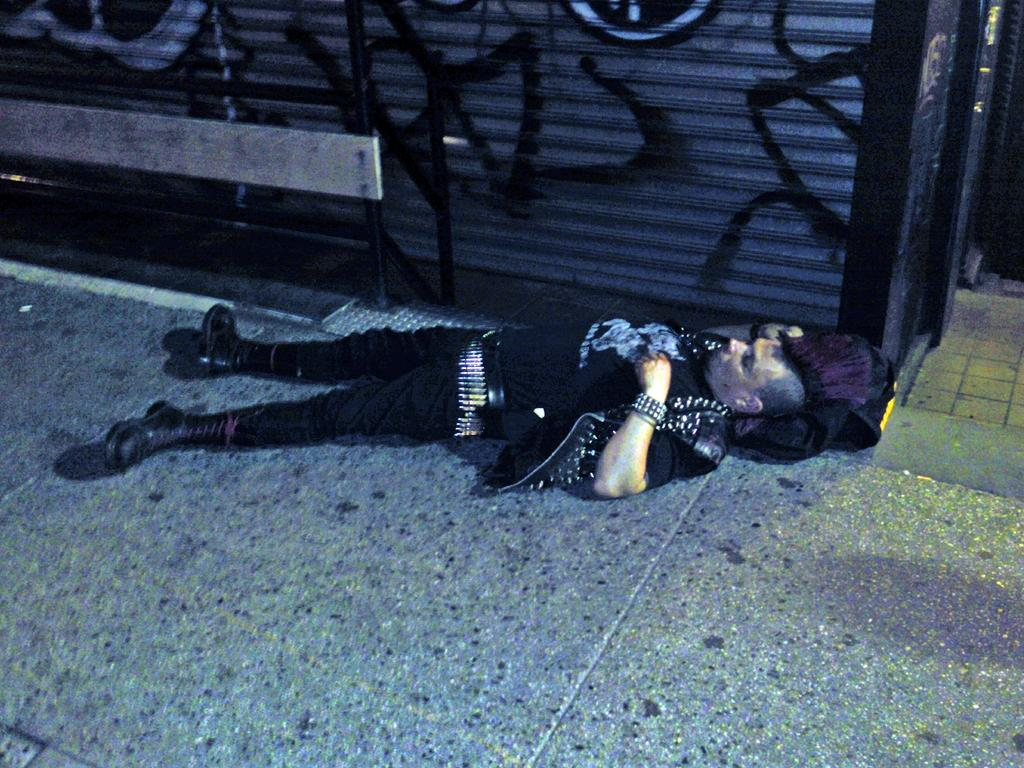What is the man in the image doing? The man is lying on the floor in the image. What is the man wearing? The man is wearing a black dress. What is supporting the man's head? There is a cloth under the man under the man's head. What objects can be seen in the background of the image? There is a shutter and a metal pole in the image. What rule is the man breaking in the image? There is no indication of any rule being broken in the image. What type of notebook is the man holding in the image? There is no notebook present in the image. 